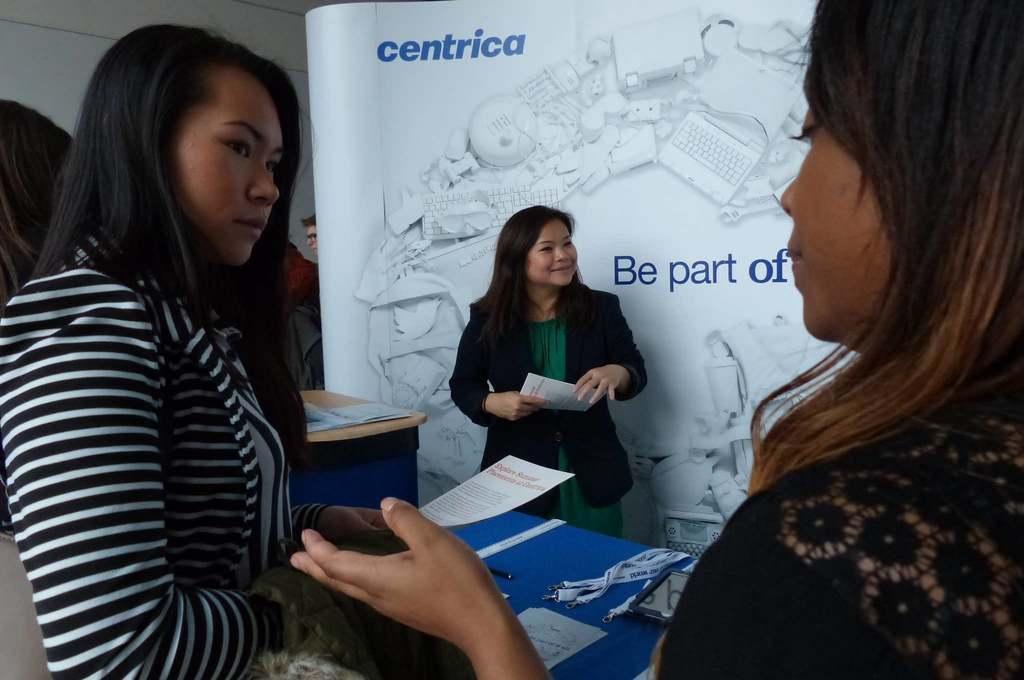Could you give a brief overview of what you see in this image? There are three ladies standing. In between them there is a table with blue color cloth, tags and papers on it. Behind them there is a poster. To the right side corner there is a lady standing. And to the left side corner there is a lady standing with black and white striped jacket. 